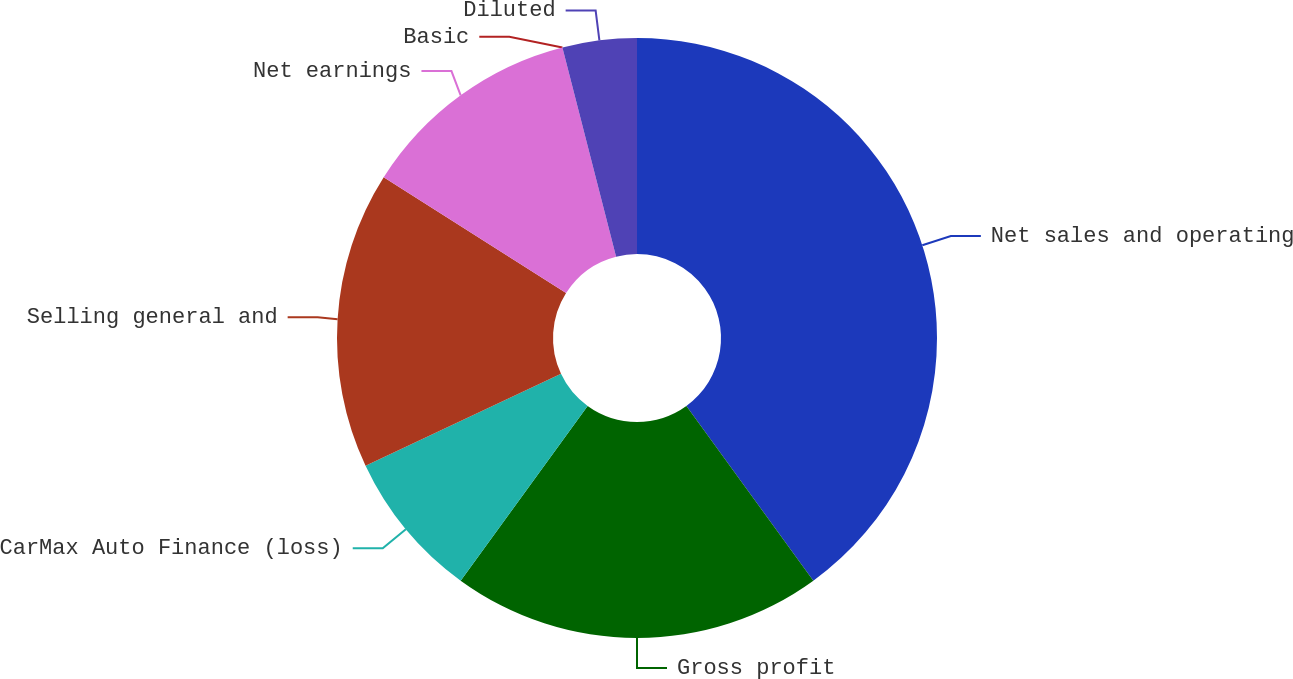Convert chart to OTSL. <chart><loc_0><loc_0><loc_500><loc_500><pie_chart><fcel>Net sales and operating<fcel>Gross profit<fcel>CarMax Auto Finance (loss)<fcel>Selling general and<fcel>Net earnings<fcel>Basic<fcel>Diluted<nl><fcel>40.0%<fcel>20.0%<fcel>8.0%<fcel>16.0%<fcel>12.0%<fcel>0.0%<fcel>4.0%<nl></chart> 